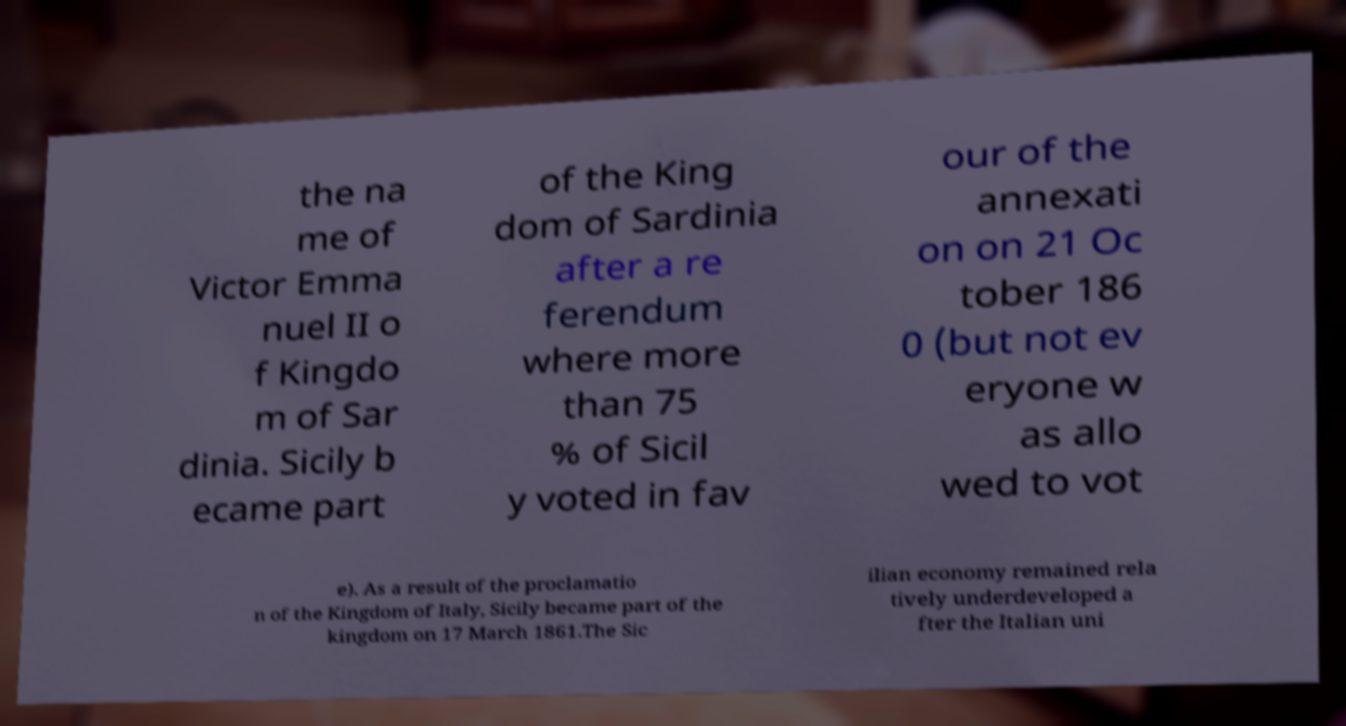I need the written content from this picture converted into text. Can you do that? the na me of Victor Emma nuel II o f Kingdo m of Sar dinia. Sicily b ecame part of the King dom of Sardinia after a re ferendum where more than 75 % of Sicil y voted in fav our of the annexati on on 21 Oc tober 186 0 (but not ev eryone w as allo wed to vot e). As a result of the proclamatio n of the Kingdom of Italy, Sicily became part of the kingdom on 17 March 1861.The Sic ilian economy remained rela tively underdeveloped a fter the Italian uni 